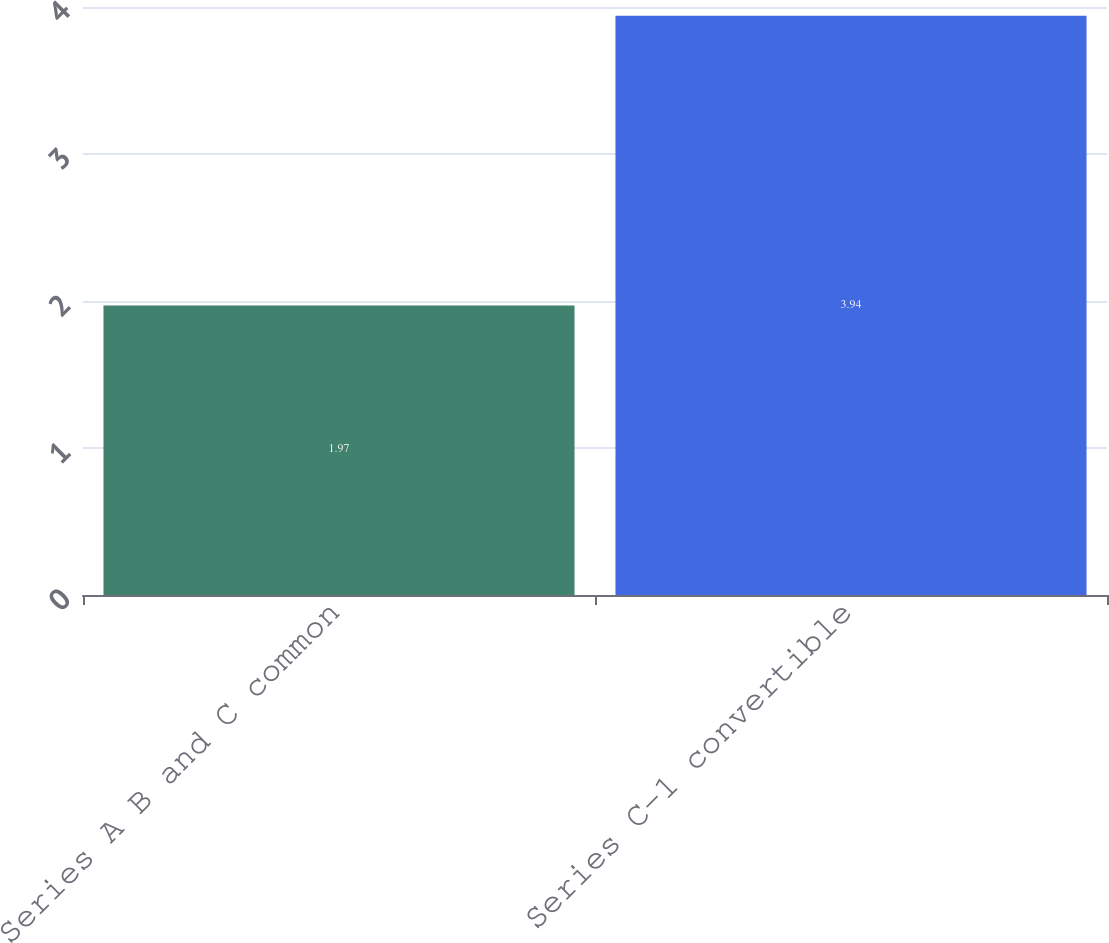Convert chart. <chart><loc_0><loc_0><loc_500><loc_500><bar_chart><fcel>Series A B and C common<fcel>Series C-1 convertible<nl><fcel>1.97<fcel>3.94<nl></chart> 